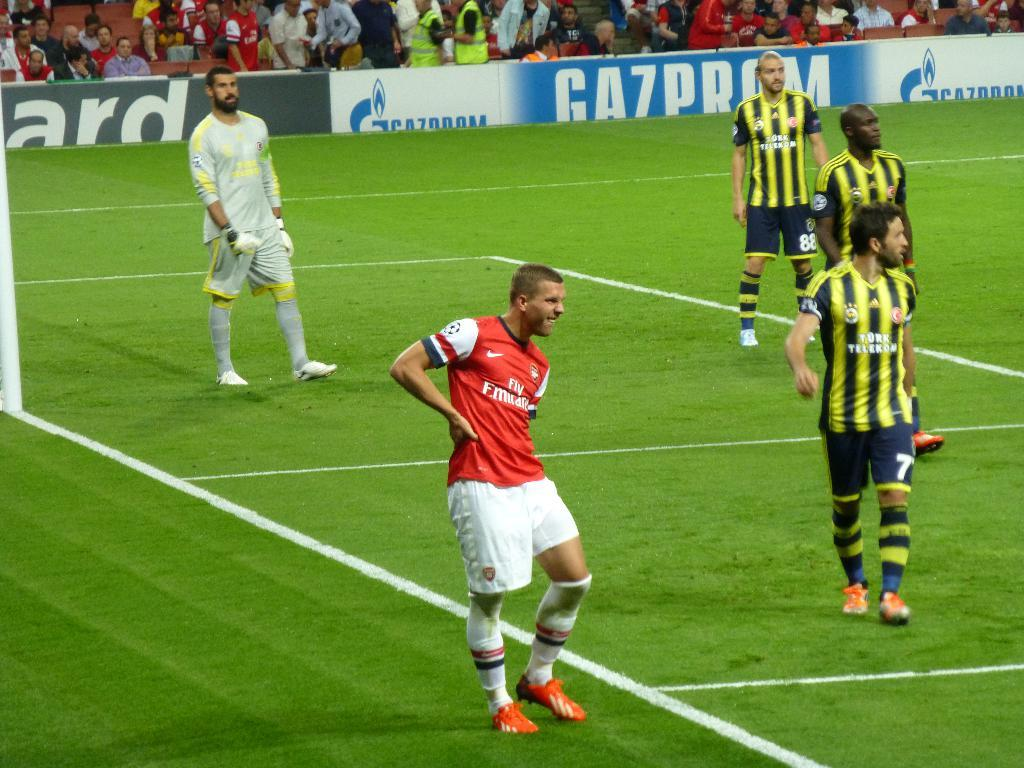<image>
Write a terse but informative summary of the picture. two soccer teams on a field sponsored by gazprom 